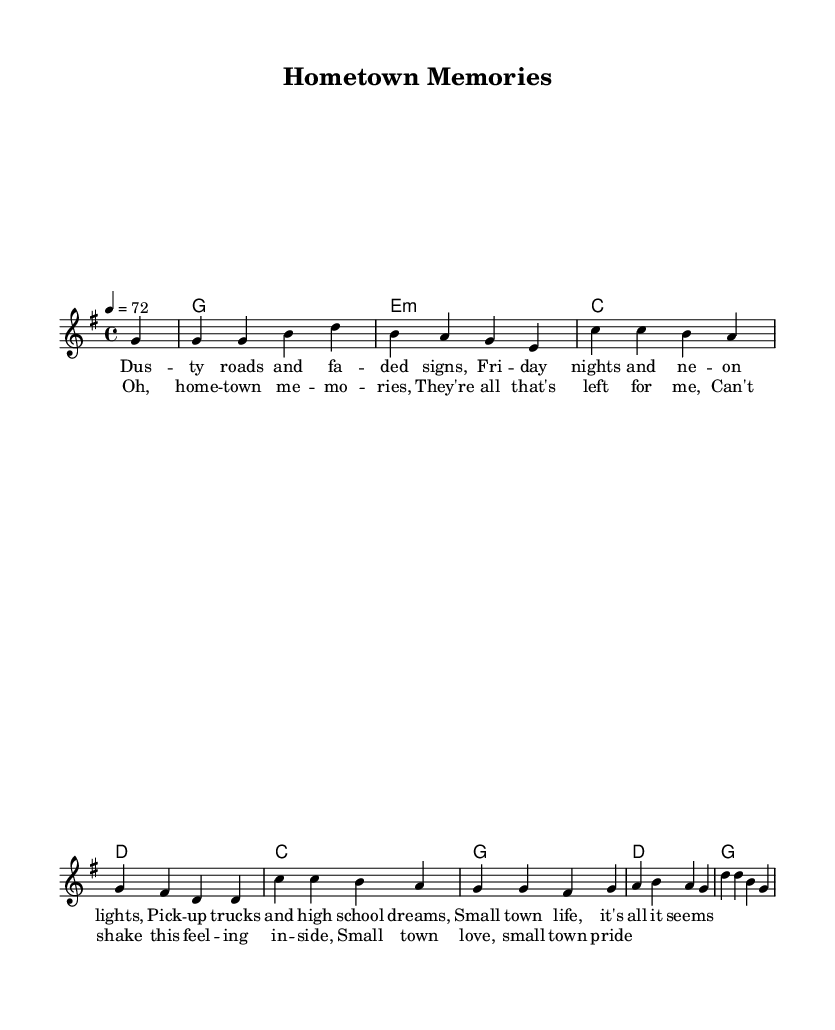What is the key signature of this music? The key signature is G major, as indicated by one sharp (F#) in the key signature section.
Answer: G major What is the time signature of this piece? The time signature is 4/4, shown at the beginning of the score, which indicates four beats per measure.
Answer: 4/4 What is the tempo marking for this music? The tempo marking indicates a speed of 72 beats per minute, stated in the tempo section at the start of the piece.
Answer: 72 How many measures are in the melody? The melody consists of 8 measures, counted from the beginning of the music to the end of the notated section.
Answer: 8 What type of chords are used in the harmony section? The harmony section consists of major and minor chords, as indicated (G major, E minor, C major, D major).
Answer: Major and minor Why are there pickup notes in the melody? Pickup notes (the partial measure at the beginning) are used to lead into the first full measure of the song, creating a natural flow for the introduction.
Answer: To lead into the full measure What themes are reflected in the lyrics of this piece? The lyrics reflect themes of nostalgia for small-town life, highlighting memories, pride, and love associated with home.
Answer: Nostalgia for small-town life 